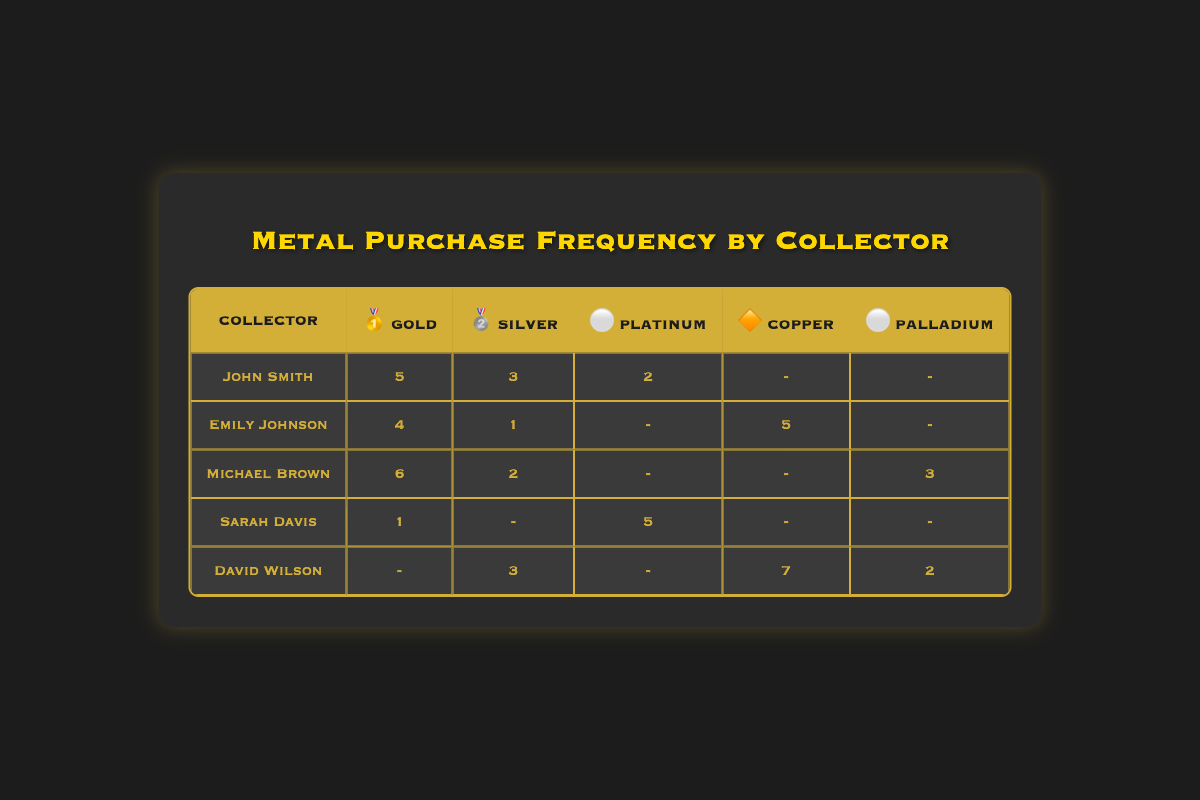What is the highest frequency of gold purchases among all collectors? To find the highest frequency of gold purchases, we can look at the gold purchase frequencies listed for each collector. John Smith has 5, Emily Johnson has 4, Michael Brown has 6, Sarah Davis has 1, and David Wilson has no purchases. The maximum value among those is 6.
Answer: 6 How many collectors purchased copper? By examining the table, we check each collector for purchases labeled as copper. Emily Johnson purchased 5, but the only other collector who has a value is David Wilson with 7. Thus, there are two collectors who purchased copper.
Answer: 2 Which collector has the least frequency of silver purchases? Looking at the silver purchases, John Smith has 3, Emily Johnson has 1, Michael Brown has 2, Sarah Davis has none, and David Wilson has 3. The lowest frequency is with Emily Johnson at 1.
Answer: Emily Johnson What is the total frequency of platinum purchases by all collectors? The table shows platinum purchases for John Smith (2), Sarah Davis (5), and the other collectors have none listed for platinum. Adding these gives 2 + 5 = 7. Therefore, the total frequency is 7.
Answer: 7 Is Michael Brown's gold purchase frequency higher than David Wilson's silver purchase frequency? Michael Brown has a gold purchase frequency of 6 while David Wilson has a silver purchase frequency of 3. Comparing these values shows that 6 is greater than 3.
Answer: Yes What is the average frequency of purchases for each metal category across all collectors? For gold, the frequencies are 5, 4, 6, 1, and 0, giving a total of 16 with an average of 16/5 = 3.2. For silver, the totals are 3, 1, 2, 0, and 3, totaling 9 with an average of 9/5 = 1.8. For platinum, we have 2 and 5, totaling 7 and averaging 7/5 = 1.4. For copper, we have 5 and 7, totaling 12 with an average of 12/2 = 6. For palladium, we have 3 and 2 (with 0 for others), totaling 5 and averaging 5/2 = 2.5. The averages are: Gold = 3.2, Silver = 1.8, Platinum = 1.4, Copper = 6, Palladium = 2.5.
Answer: Average for Gold: 3.2, Silver: 1.8, Platinum: 1.4, Copper: 6, Palladium: 2.5 Who has the most purchases in the copper category, and how many purchases did they make? Checking the copper purchases, David Wilson has 7 purchases while Emily Johnson has 5. The maximum belongs to David Wilson with 7.
Answer: David Wilson, 7 How many collectors have made no purchases of platinum? Looking at the table, the collectors who made no platinum purchases are John Smith, Emily Johnson, Michael Brown, and David Wilson (Sarah Davis is the only one with platinum purchases). Therefore, 4 collectors have made no purchases of platinum.
Answer: 4 